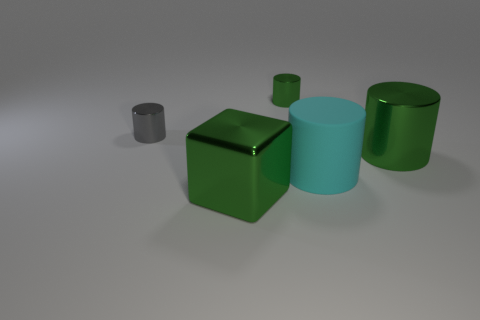Is the big metal block the same color as the big shiny cylinder?
Your answer should be very brief. Yes. How many tiny green shiny objects have the same shape as the gray metal thing?
Your answer should be very brief. 1. Is the number of big matte things behind the tiny gray metal cylinder the same as the number of rubber cylinders in front of the metallic block?
Your answer should be very brief. Yes. What is the shape of the green object that is the same size as the gray cylinder?
Make the answer very short. Cylinder. What number of objects are shiny cylinders that are right of the matte cylinder or tiny metal things that are to the right of the tiny gray cylinder?
Make the answer very short. 2. Do the thing on the right side of the cyan cylinder and the gray thing have the same size?
Your answer should be compact. No. The gray metallic object that is the same shape as the big cyan object is what size?
Your answer should be very brief. Small. What material is the green cylinder that is the same size as the gray cylinder?
Ensure brevity in your answer.  Metal. What material is the tiny green object that is the same shape as the gray shiny object?
Provide a succinct answer. Metal. What number of other things are there of the same size as the cyan matte cylinder?
Your answer should be compact. 2. 